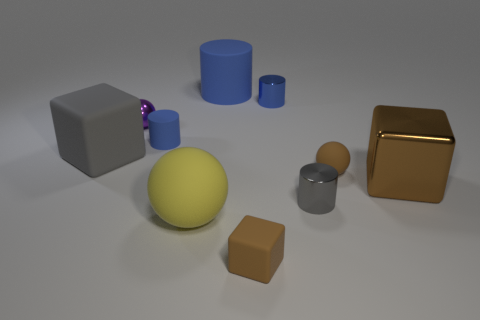What number of blue things are large cylinders or small spheres?
Your response must be concise. 1. What number of brown objects are the same shape as the large gray rubber object?
Give a very brief answer. 2. What is the shape of the yellow object that is the same size as the brown metal object?
Your response must be concise. Sphere. There is a tiny purple ball; are there any small blue things behind it?
Ensure brevity in your answer.  Yes. Is there a tiny blue cylinder that is on the right side of the large rubber thing that is behind the purple object?
Offer a very short reply. Yes. Is the number of large matte cubes that are on the right side of the small gray cylinder less than the number of brown matte spheres that are behind the big yellow thing?
Your answer should be very brief. Yes. There is a gray rubber object; what shape is it?
Provide a short and direct response. Cube. What is the small blue cylinder that is right of the big cylinder made of?
Keep it short and to the point. Metal. How big is the brown block right of the tiny brown object that is to the left of the sphere that is on the right side of the tiny brown cube?
Your answer should be compact. Large. Are the sphere behind the tiny brown ball and the cylinder in front of the large metallic object made of the same material?
Provide a succinct answer. Yes. 